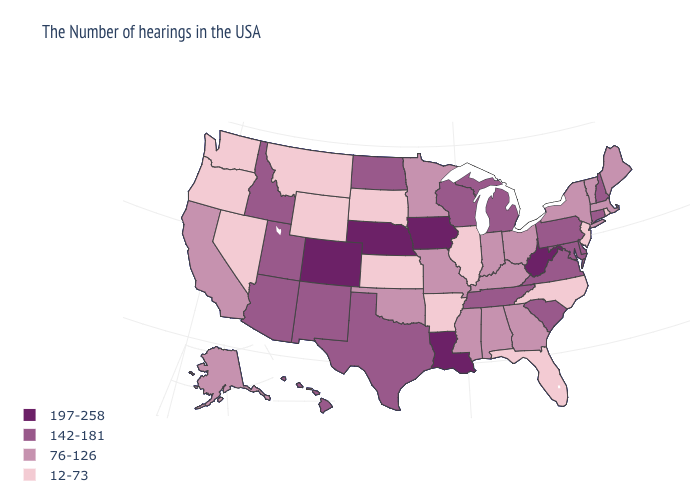Does New Hampshire have a higher value than Massachusetts?
Keep it brief. Yes. Does Wisconsin have the same value as Arizona?
Quick response, please. Yes. What is the value of Utah?
Answer briefly. 142-181. Which states have the highest value in the USA?
Write a very short answer. West Virginia, Louisiana, Iowa, Nebraska, Colorado. Does New Jersey have the highest value in the Northeast?
Write a very short answer. No. Name the states that have a value in the range 12-73?
Quick response, please. Rhode Island, New Jersey, North Carolina, Florida, Illinois, Arkansas, Kansas, South Dakota, Wyoming, Montana, Nevada, Washington, Oregon. Which states have the lowest value in the USA?
Write a very short answer. Rhode Island, New Jersey, North Carolina, Florida, Illinois, Arkansas, Kansas, South Dakota, Wyoming, Montana, Nevada, Washington, Oregon. Does Alaska have a higher value than Oregon?
Keep it brief. Yes. Among the states that border New York , does Pennsylvania have the highest value?
Answer briefly. Yes. What is the highest value in the West ?
Be succinct. 197-258. Name the states that have a value in the range 12-73?
Be succinct. Rhode Island, New Jersey, North Carolina, Florida, Illinois, Arkansas, Kansas, South Dakota, Wyoming, Montana, Nevada, Washington, Oregon. Name the states that have a value in the range 142-181?
Answer briefly. New Hampshire, Connecticut, Delaware, Maryland, Pennsylvania, Virginia, South Carolina, Michigan, Tennessee, Wisconsin, Texas, North Dakota, New Mexico, Utah, Arizona, Idaho, Hawaii. What is the lowest value in states that border Louisiana?
Answer briefly. 12-73. Does Hawaii have the same value as Arizona?
Give a very brief answer. Yes. Which states have the lowest value in the USA?
Quick response, please. Rhode Island, New Jersey, North Carolina, Florida, Illinois, Arkansas, Kansas, South Dakota, Wyoming, Montana, Nevada, Washington, Oregon. 